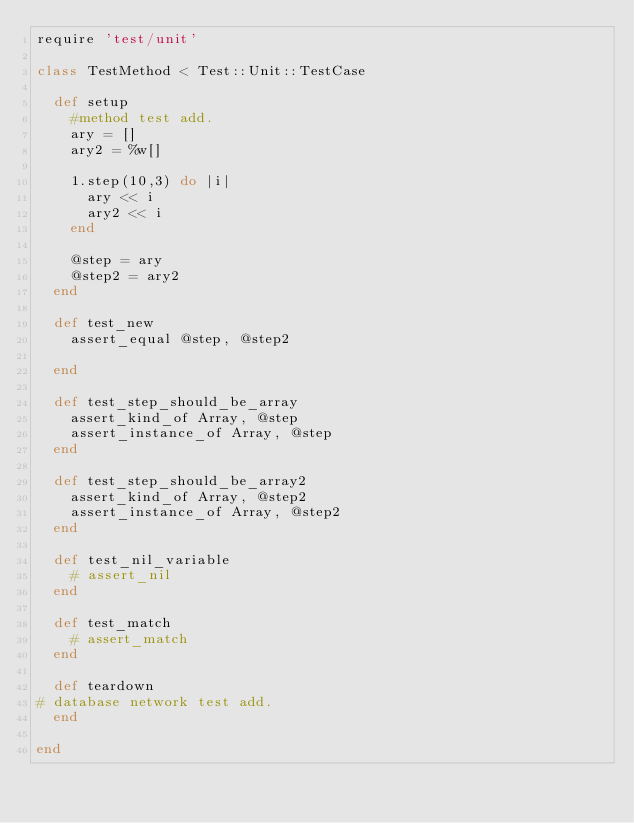<code> <loc_0><loc_0><loc_500><loc_500><_Ruby_>require 'test/unit'

class TestMethod < Test::Unit::TestCase

  def setup
    #method test add.
    ary = []
    ary2 = %w[]

    1.step(10,3) do |i|
      ary << i
      ary2 << i
    end

    @step = ary
    @step2 = ary2
  end

  def test_new
    assert_equal @step, @step2

  end

  def test_step_should_be_array
    assert_kind_of Array, @step
    assert_instance_of Array, @step
  end

  def test_step_should_be_array2
    assert_kind_of Array, @step2
    assert_instance_of Array, @step2
  end

  def test_nil_variable
    # assert_nil
  end

  def test_match
    # assert_match
  end

  def teardown
# database network test add.
  end

end
</code> 